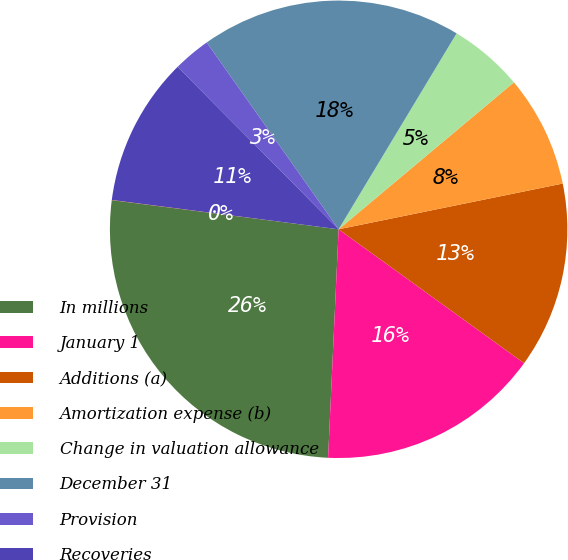Convert chart to OTSL. <chart><loc_0><loc_0><loc_500><loc_500><pie_chart><fcel>In millions<fcel>January 1<fcel>Additions (a)<fcel>Amortization expense (b)<fcel>Change in valuation allowance<fcel>December 31<fcel>Provision<fcel>Recoveries<fcel>Other (b)<nl><fcel>26.3%<fcel>15.78%<fcel>13.16%<fcel>7.9%<fcel>5.27%<fcel>18.41%<fcel>2.64%<fcel>10.53%<fcel>0.01%<nl></chart> 